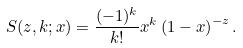Convert formula to latex. <formula><loc_0><loc_0><loc_500><loc_500>S ( z , k ; x ) = \frac { ( - 1 ) ^ { k } } { k ! } x ^ { k } \left ( 1 - x \right ) ^ { - z } .</formula> 